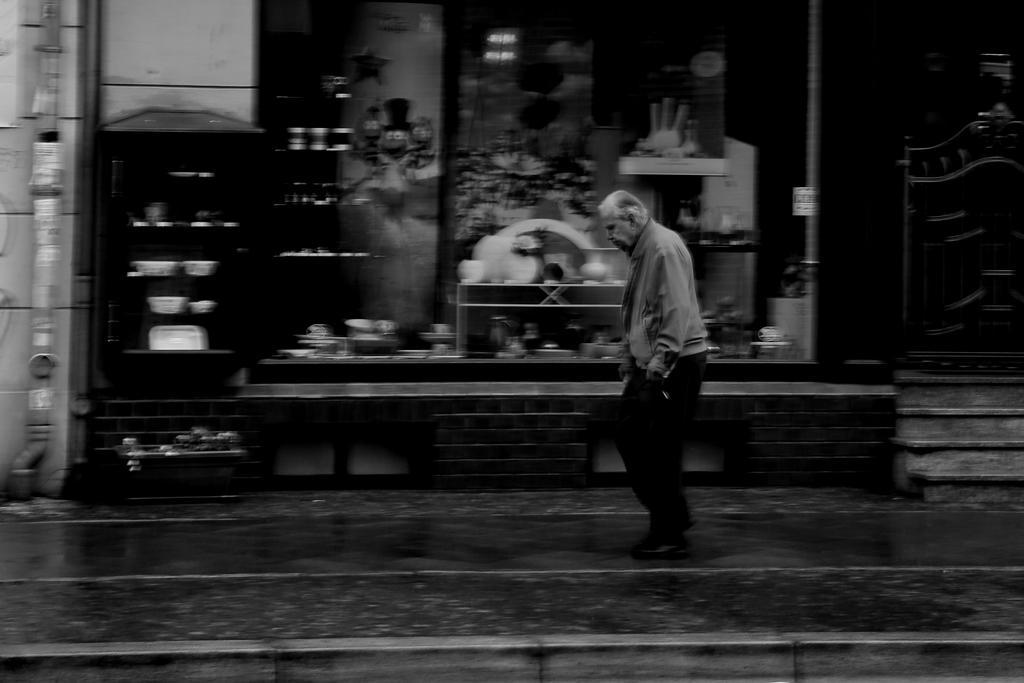Can you describe this image briefly? In the picture we can see black and white photograph on a man walking on the path and beside him we can see a shop with glass to it and from the glass we can see some things are placed in the shop and beside the shop we can see a gate with some steps near it. 